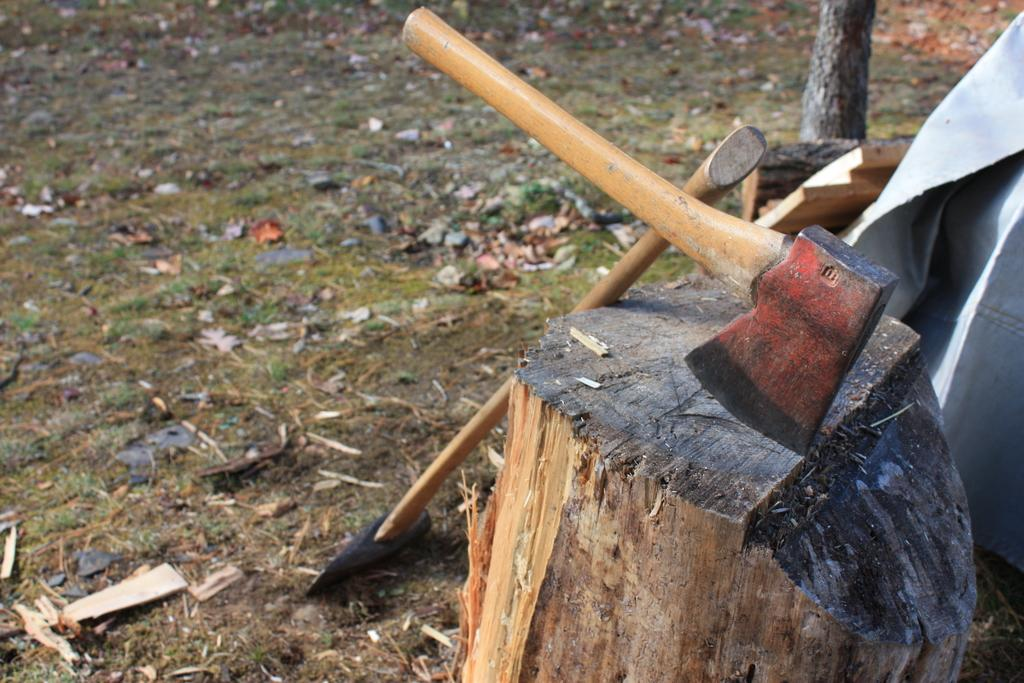What objects are present in the image that are used for cutting? There are two axes in the image, which are used for cutting. What is the log being used for in the image? The log is likely being used as a cutting surface or support for the axes. What can be seen in the background of the image? The ground is visible in the background of the image. What material is visible on the log? Bark is visible on the log. What type of rice is being cooked in the image? There is no rice present in the image; it features two axes and a log. What treatment is being administered to the zebra in the image? There is no zebra present in the image; it features two axes and a log. 